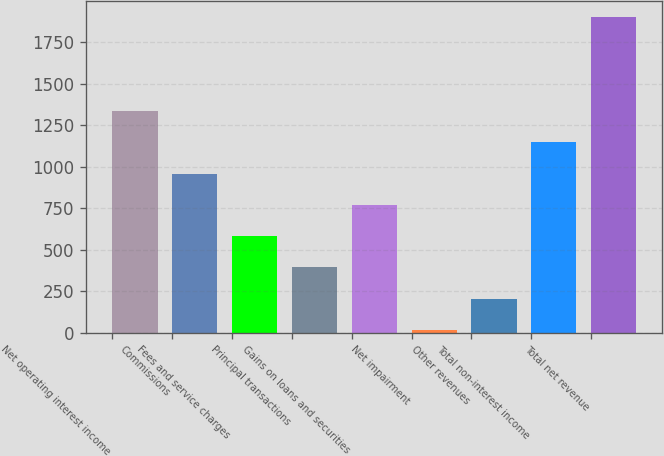Convert chart to OTSL. <chart><loc_0><loc_0><loc_500><loc_500><bar_chart><fcel>Net operating interest income<fcel>Commissions<fcel>Fees and service charges<fcel>Principal transactions<fcel>Gains on loans and securities<fcel>Net impairment<fcel>Other revenues<fcel>Total non-interest income<fcel>Total net revenue<nl><fcel>1334.72<fcel>958.2<fcel>581.68<fcel>393.42<fcel>769.94<fcel>16.9<fcel>205.16<fcel>1146.46<fcel>1899.5<nl></chart> 